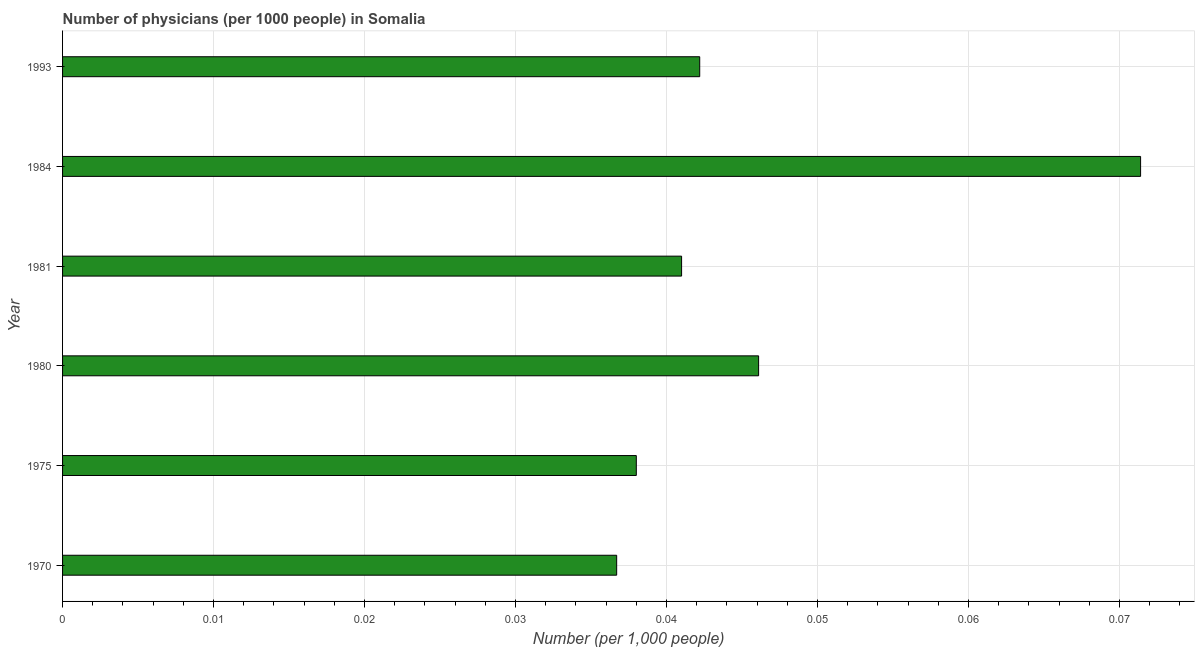Does the graph contain any zero values?
Offer a very short reply. No. What is the title of the graph?
Ensure brevity in your answer.  Number of physicians (per 1000 people) in Somalia. What is the label or title of the X-axis?
Keep it short and to the point. Number (per 1,0 people). What is the label or title of the Y-axis?
Your response must be concise. Year. What is the number of physicians in 1980?
Your response must be concise. 0.05. Across all years, what is the maximum number of physicians?
Your answer should be compact. 0.07. Across all years, what is the minimum number of physicians?
Offer a very short reply. 0.04. In which year was the number of physicians minimum?
Offer a very short reply. 1970. What is the sum of the number of physicians?
Give a very brief answer. 0.28. What is the difference between the number of physicians in 1975 and 1993?
Your response must be concise. -0. What is the average number of physicians per year?
Offer a terse response. 0.05. What is the median number of physicians?
Your response must be concise. 0.04. Do a majority of the years between 1975 and 1980 (inclusive) have number of physicians greater than 0.066 ?
Your answer should be very brief. No. What is the ratio of the number of physicians in 1981 to that in 1984?
Your response must be concise. 0.57. Is the difference between the number of physicians in 1980 and 1993 greater than the difference between any two years?
Your answer should be very brief. No. What is the difference between the highest and the second highest number of physicians?
Your response must be concise. 0.03. Is the sum of the number of physicians in 1970 and 1981 greater than the maximum number of physicians across all years?
Provide a succinct answer. Yes. What is the difference between the highest and the lowest number of physicians?
Give a very brief answer. 0.03. In how many years, is the number of physicians greater than the average number of physicians taken over all years?
Offer a terse response. 2. Are the values on the major ticks of X-axis written in scientific E-notation?
Give a very brief answer. No. What is the Number (per 1,000 people) of 1970?
Ensure brevity in your answer.  0.04. What is the Number (per 1,000 people) in 1975?
Give a very brief answer. 0.04. What is the Number (per 1,000 people) of 1980?
Keep it short and to the point. 0.05. What is the Number (per 1,000 people) of 1981?
Your answer should be very brief. 0.04. What is the Number (per 1,000 people) in 1984?
Ensure brevity in your answer.  0.07. What is the Number (per 1,000 people) of 1993?
Your answer should be compact. 0.04. What is the difference between the Number (per 1,000 people) in 1970 and 1975?
Your response must be concise. -0. What is the difference between the Number (per 1,000 people) in 1970 and 1980?
Give a very brief answer. -0.01. What is the difference between the Number (per 1,000 people) in 1970 and 1981?
Ensure brevity in your answer.  -0. What is the difference between the Number (per 1,000 people) in 1970 and 1984?
Provide a succinct answer. -0.03. What is the difference between the Number (per 1,000 people) in 1970 and 1993?
Provide a succinct answer. -0.01. What is the difference between the Number (per 1,000 people) in 1975 and 1980?
Make the answer very short. -0.01. What is the difference between the Number (per 1,000 people) in 1975 and 1981?
Offer a terse response. -0. What is the difference between the Number (per 1,000 people) in 1975 and 1984?
Provide a succinct answer. -0.03. What is the difference between the Number (per 1,000 people) in 1975 and 1993?
Your answer should be very brief. -0. What is the difference between the Number (per 1,000 people) in 1980 and 1981?
Ensure brevity in your answer.  0.01. What is the difference between the Number (per 1,000 people) in 1980 and 1984?
Offer a very short reply. -0.03. What is the difference between the Number (per 1,000 people) in 1980 and 1993?
Make the answer very short. 0. What is the difference between the Number (per 1,000 people) in 1981 and 1984?
Your response must be concise. -0.03. What is the difference between the Number (per 1,000 people) in 1981 and 1993?
Your answer should be compact. -0. What is the difference between the Number (per 1,000 people) in 1984 and 1993?
Provide a succinct answer. 0.03. What is the ratio of the Number (per 1,000 people) in 1970 to that in 1975?
Your answer should be compact. 0.97. What is the ratio of the Number (per 1,000 people) in 1970 to that in 1980?
Offer a very short reply. 0.8. What is the ratio of the Number (per 1,000 people) in 1970 to that in 1981?
Your answer should be compact. 0.9. What is the ratio of the Number (per 1,000 people) in 1970 to that in 1984?
Provide a succinct answer. 0.51. What is the ratio of the Number (per 1,000 people) in 1970 to that in 1993?
Provide a succinct answer. 0.87. What is the ratio of the Number (per 1,000 people) in 1975 to that in 1980?
Your answer should be compact. 0.82. What is the ratio of the Number (per 1,000 people) in 1975 to that in 1981?
Your answer should be very brief. 0.93. What is the ratio of the Number (per 1,000 people) in 1975 to that in 1984?
Your answer should be very brief. 0.53. What is the ratio of the Number (per 1,000 people) in 1980 to that in 1981?
Keep it short and to the point. 1.12. What is the ratio of the Number (per 1,000 people) in 1980 to that in 1984?
Offer a terse response. 0.65. What is the ratio of the Number (per 1,000 people) in 1980 to that in 1993?
Offer a terse response. 1.09. What is the ratio of the Number (per 1,000 people) in 1981 to that in 1984?
Provide a short and direct response. 0.57. What is the ratio of the Number (per 1,000 people) in 1981 to that in 1993?
Make the answer very short. 0.97. What is the ratio of the Number (per 1,000 people) in 1984 to that in 1993?
Your answer should be compact. 1.69. 